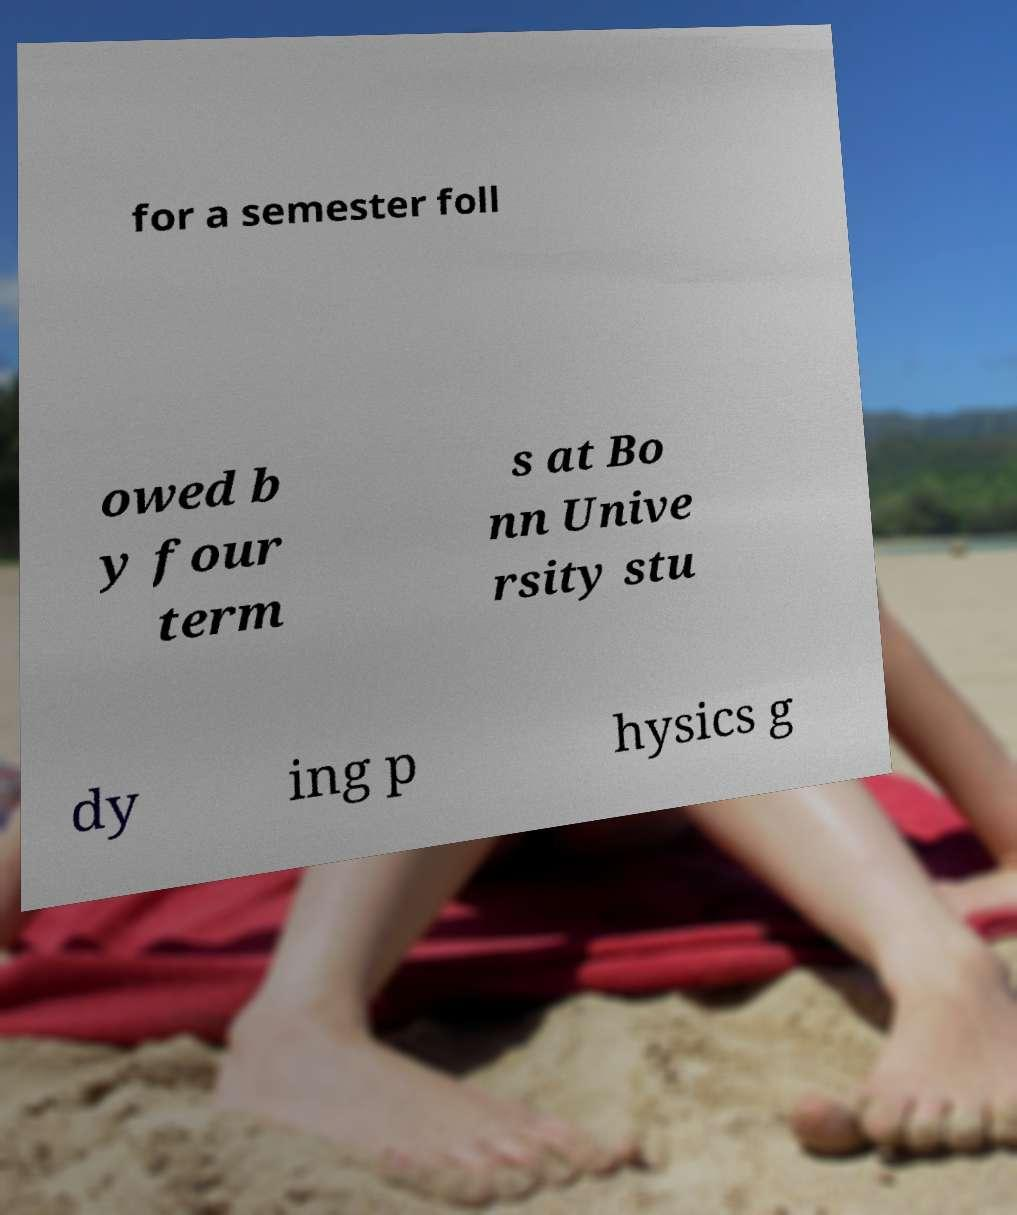For documentation purposes, I need the text within this image transcribed. Could you provide that? for a semester foll owed b y four term s at Bo nn Unive rsity stu dy ing p hysics g 